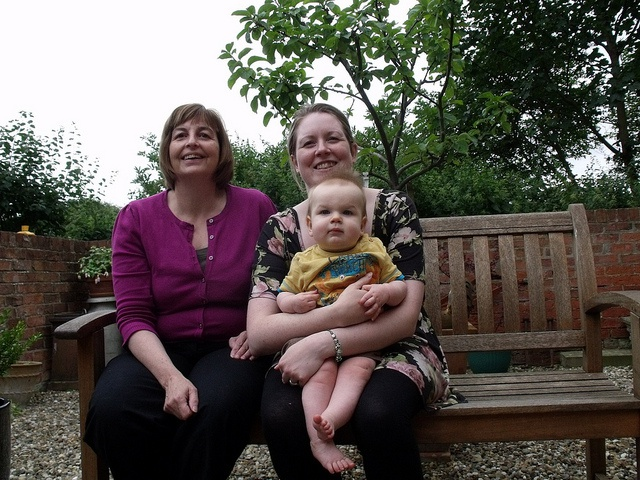Describe the objects in this image and their specific colors. I can see people in white, black, gray, and darkgray tones, bench in white, black, and gray tones, and people in white, black, purple, and brown tones in this image. 